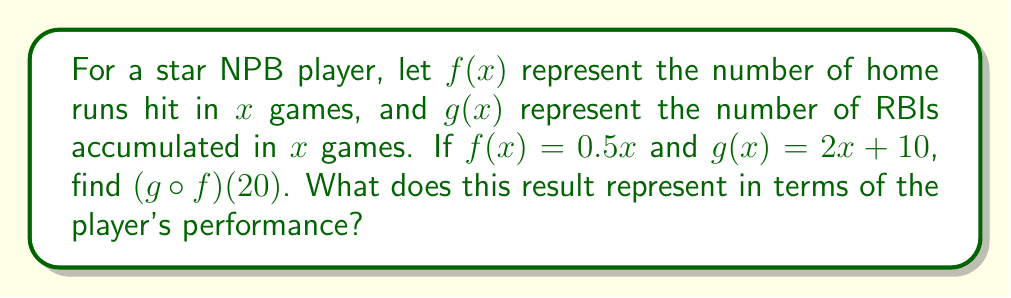Can you answer this question? To solve this problem, we need to follow these steps:

1) First, recall that $(g \circ f)(x)$ means we apply function $f$ first, then apply function $g$ to the result.

2) We're given that $f(x) = 0.5x$ and $g(x) = 2x + 10$.

3) We need to find $(g \circ f)(20)$, so let's start by calculating $f(20)$:

   $f(20) = 0.5(20) = 10$

4) Now we need to apply $g$ to this result:

   $g(f(20)) = g(10)$

5) Calculate $g(10)$:

   $g(10) = 2(10) + 10 = 20 + 10 = 30$

6) Therefore, $(g \circ f)(20) = 30$

This result represents the number of RBIs (g) the player accumulates based on the number of home runs (f) hit in 20 games. In other words, if the player hits home runs at a rate of 0.5 per game for 20 games (10 home runs total), they would accumulate 30 RBIs.
Answer: 30 RBIs 